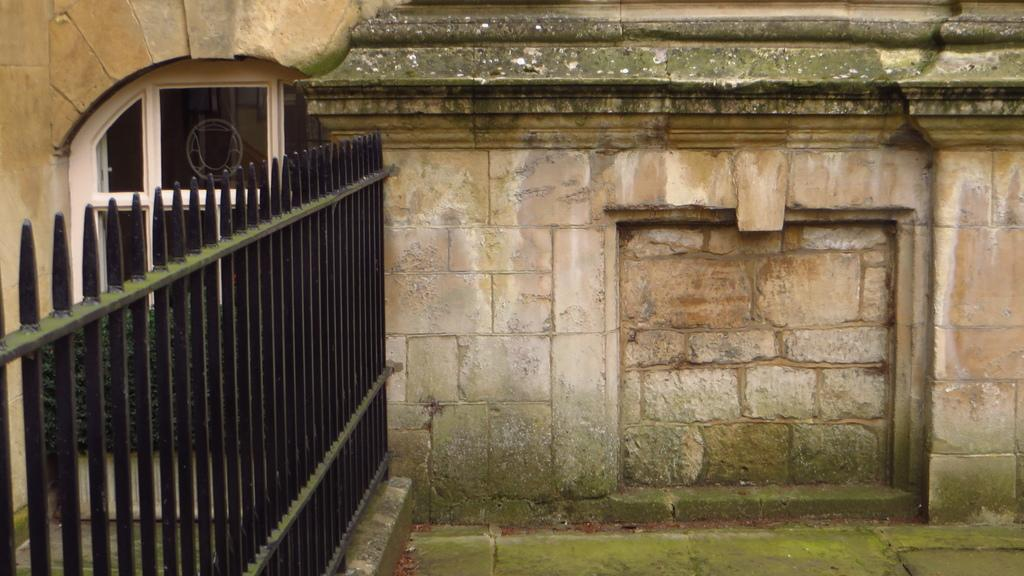What type of structure can be seen in the image? There is fencing in the image. What architectural feature is visible in the image? There is a window in the image. What other element can be seen in the image? There is a wall in the image. What type of arch can be seen in the image? There is no arch present in the image; it features fencing, a window, and a wall. How many geese are visible in the image? There are no geese present in the image. 